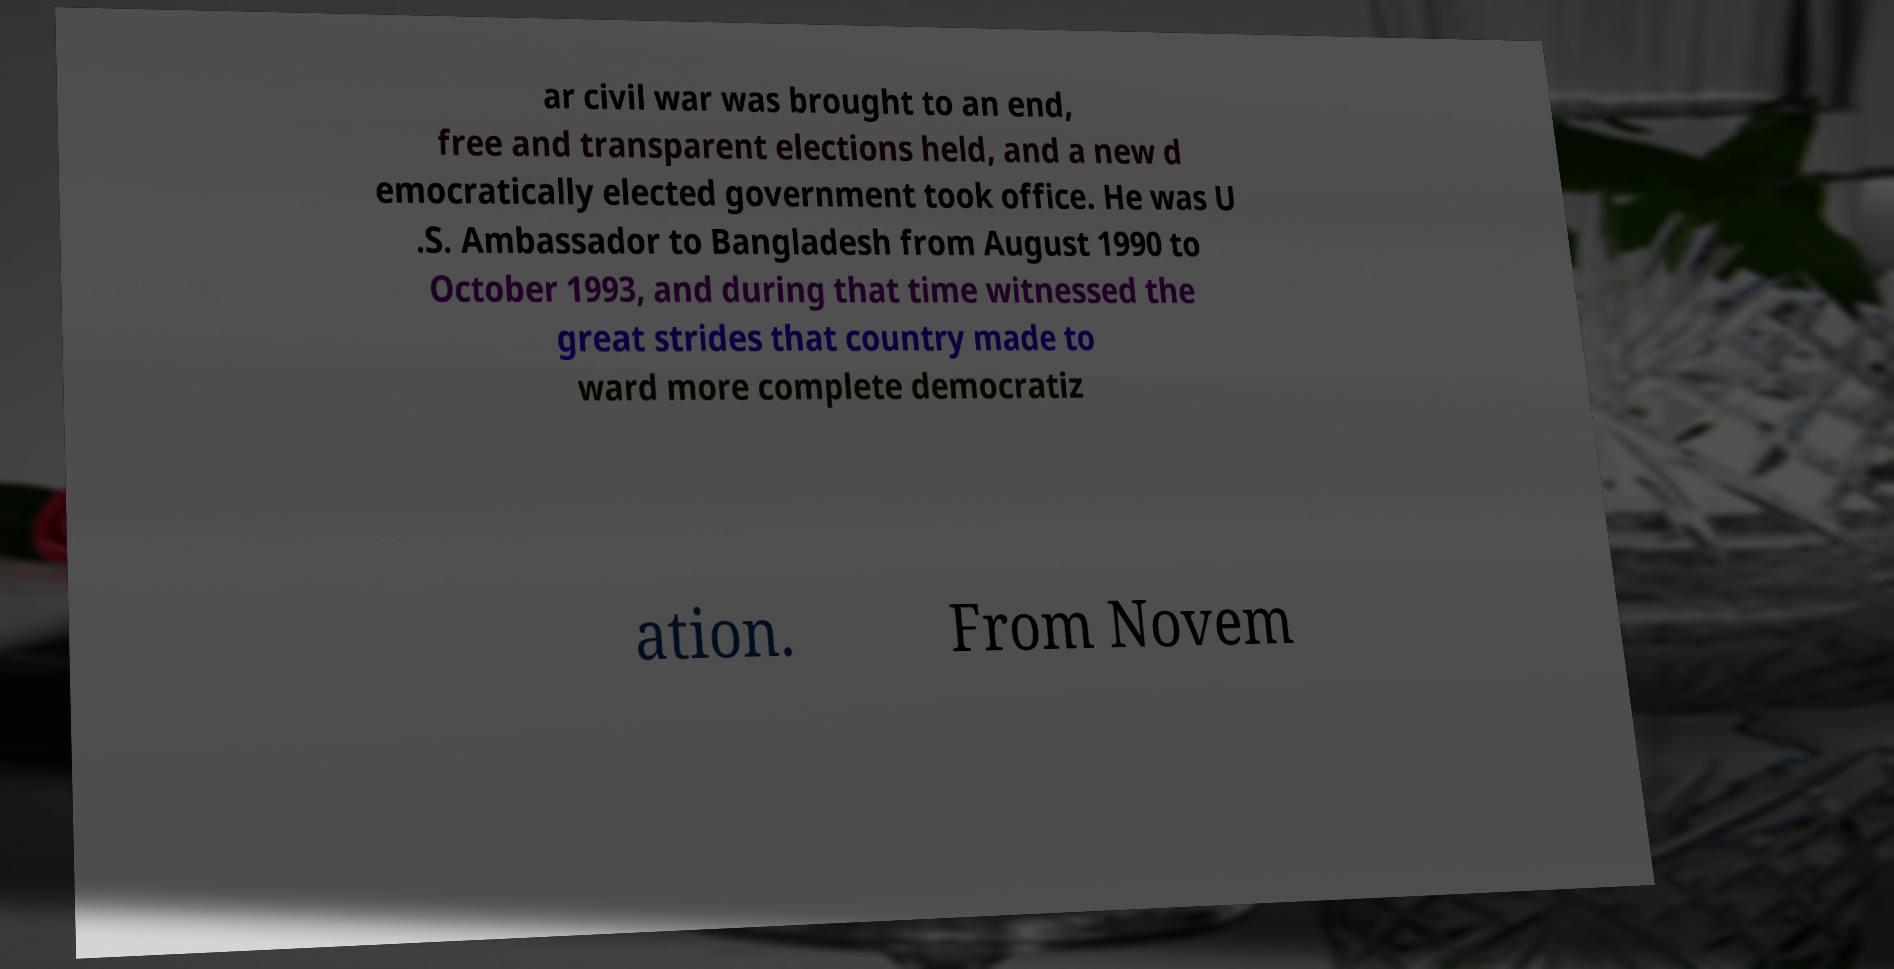What messages or text are displayed in this image? I need them in a readable, typed format. ar civil war was brought to an end, free and transparent elections held, and a new d emocratically elected government took office. He was U .S. Ambassador to Bangladesh from August 1990 to October 1993, and during that time witnessed the great strides that country made to ward more complete democratiz ation. From Novem 